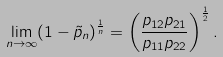Convert formula to latex. <formula><loc_0><loc_0><loc_500><loc_500>\lim _ { n \rightarrow \infty } ( 1 - \tilde { p } _ { n } ) ^ { \frac { 1 } { n } } = \left ( \frac { p _ { 1 2 } p _ { 2 1 } } { p _ { 1 1 } p _ { 2 2 } } \right ) ^ { \frac { 1 } { 2 } } .</formula> 